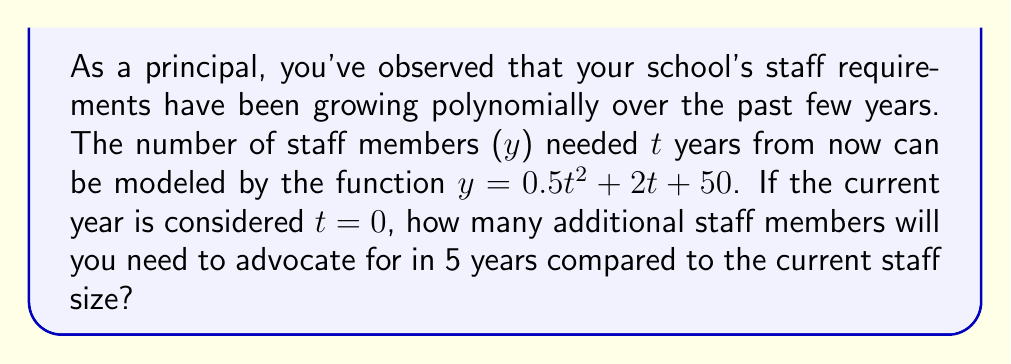Give your solution to this math problem. Let's approach this step-by-step:

1) The polynomial function given is $y = 0.5t^2 + 2t + 50$, where y is the number of staff members and t is the number of years from now.

2) To find the current staff size (at t = 0):
   $y = 0.5(0)^2 + 2(0) + 50 = 50$ staff members

3) To find the staff size in 5 years (at t = 5):
   $y = 0.5(5)^2 + 2(5) + 50$
   $= 0.5(25) + 10 + 50$
   $= 12.5 + 10 + 50$
   $= 72.5$ staff members

4) The question asks for additional staff members needed, so we calculate the difference:
   Additional staff = Staff at t=5 - Staff at t=0
   $= 72.5 - 50 = 22.5$

5) Since we can't have a fractional number of staff members, we round up to the nearest whole number.
Answer: 23 additional staff members 